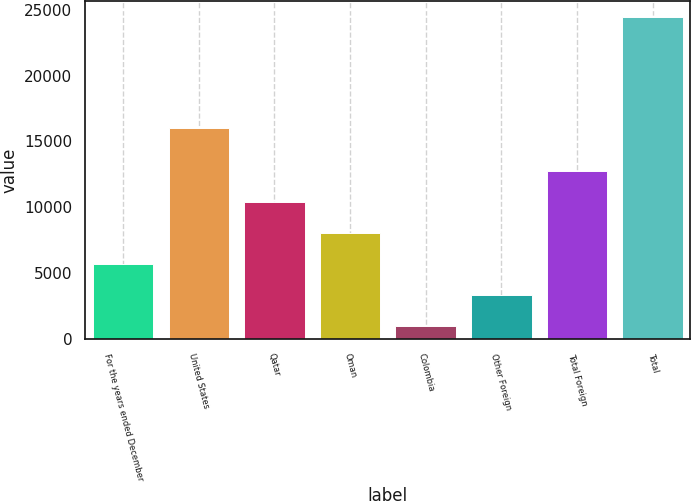Convert chart to OTSL. <chart><loc_0><loc_0><loc_500><loc_500><bar_chart><fcel>For the years ended December<fcel>United States<fcel>Qatar<fcel>Oman<fcel>Colombia<fcel>Other Foreign<fcel>Total Foreign<fcel>Total<nl><fcel>5708.6<fcel>16009<fcel>10395.2<fcel>8051.9<fcel>1022<fcel>3365.3<fcel>12738.5<fcel>24455<nl></chart> 